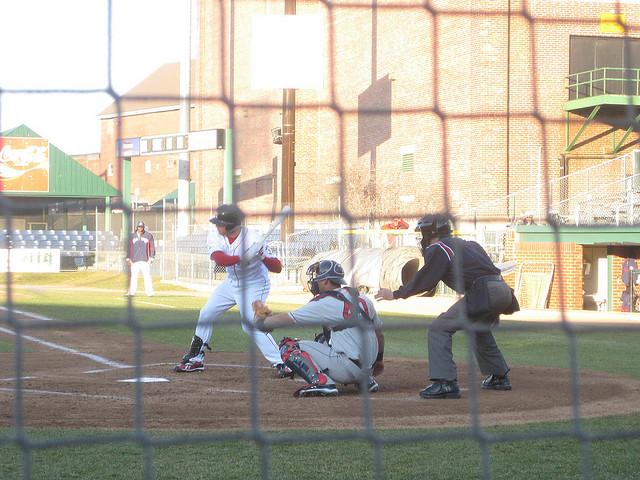What is in the background?
Keep it brief. Building. What is the person on the floor holding?
Give a very brief answer. Mitt. What are the men doing?
Quick response, please. Playing baseball. What sport are they playing?
Answer briefly. Baseball. 